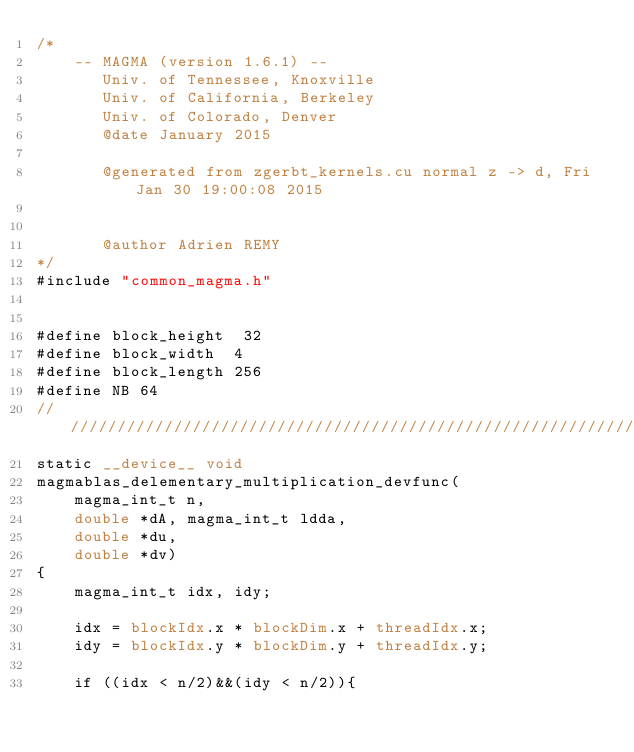Convert code to text. <code><loc_0><loc_0><loc_500><loc_500><_Cuda_>/*
    -- MAGMA (version 1.6.1) --
       Univ. of Tennessee, Knoxville
       Univ. of California, Berkeley
       Univ. of Colorado, Denver
       @date January 2015

       @generated from zgerbt_kernels.cu normal z -> d, Fri Jan 30 19:00:08 2015


       @author Adrien REMY
*/
#include "common_magma.h"


#define block_height  32
#define block_width  4
#define block_length 256
#define NB 64
/////////////////////////////////////////////////////////////////////////////////////////////////////////////
static __device__ void 
magmablas_delementary_multiplication_devfunc(
    magma_int_t n,
    double *dA, magma_int_t ldda, 
    double *du, 
    double *dv)
{    
    magma_int_t idx, idy;

    idx = blockIdx.x * blockDim.x + threadIdx.x;
    idy = blockIdx.y * blockDim.y + threadIdx.y;

    if ((idx < n/2)&&(idy < n/2)){
</code> 